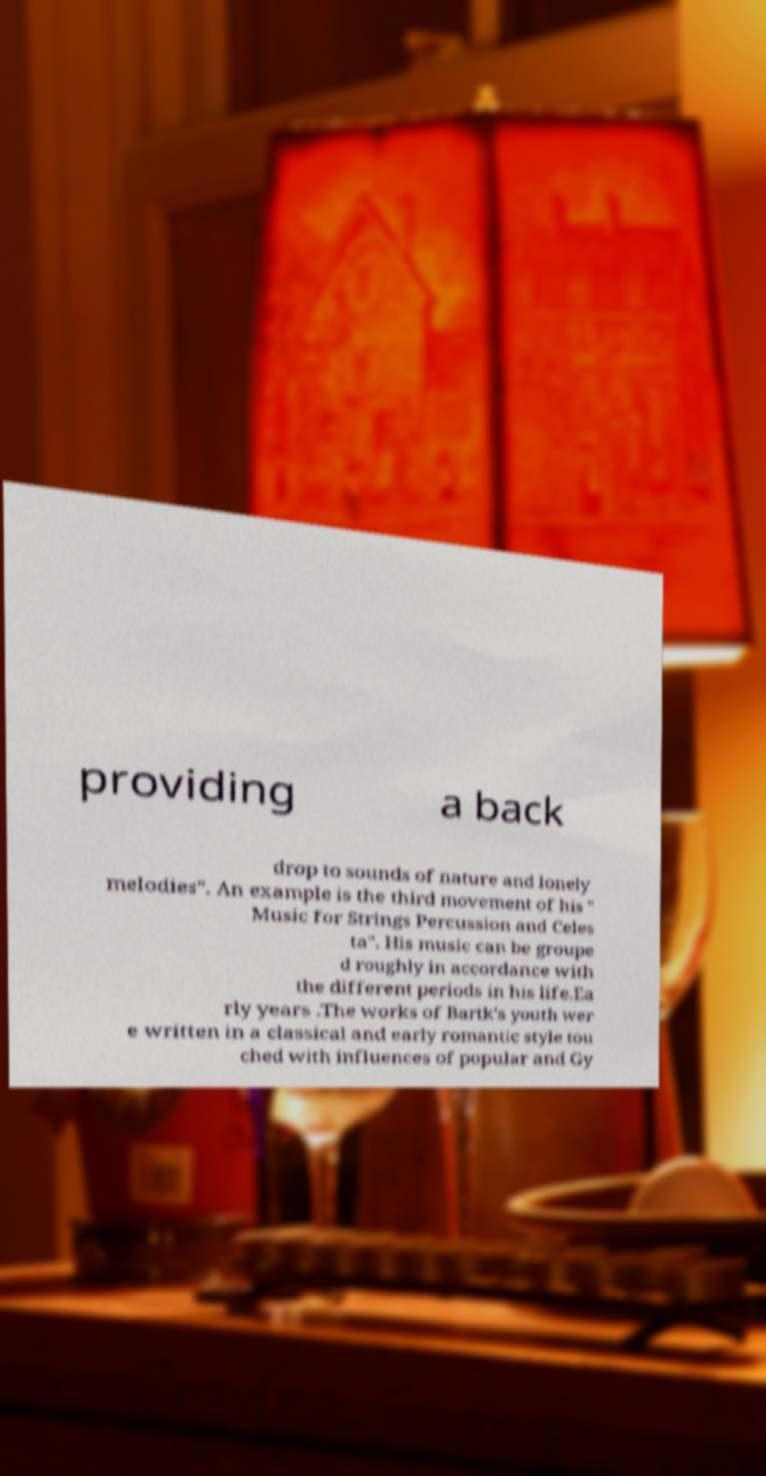Could you extract and type out the text from this image? providing a back drop to sounds of nature and lonely melodies". An example is the third movement of his " Music for Strings Percussion and Celes ta". His music can be groupe d roughly in accordance with the different periods in his life.Ea rly years .The works of Bartk's youth wer e written in a classical and early romantic style tou ched with influences of popular and Gy 